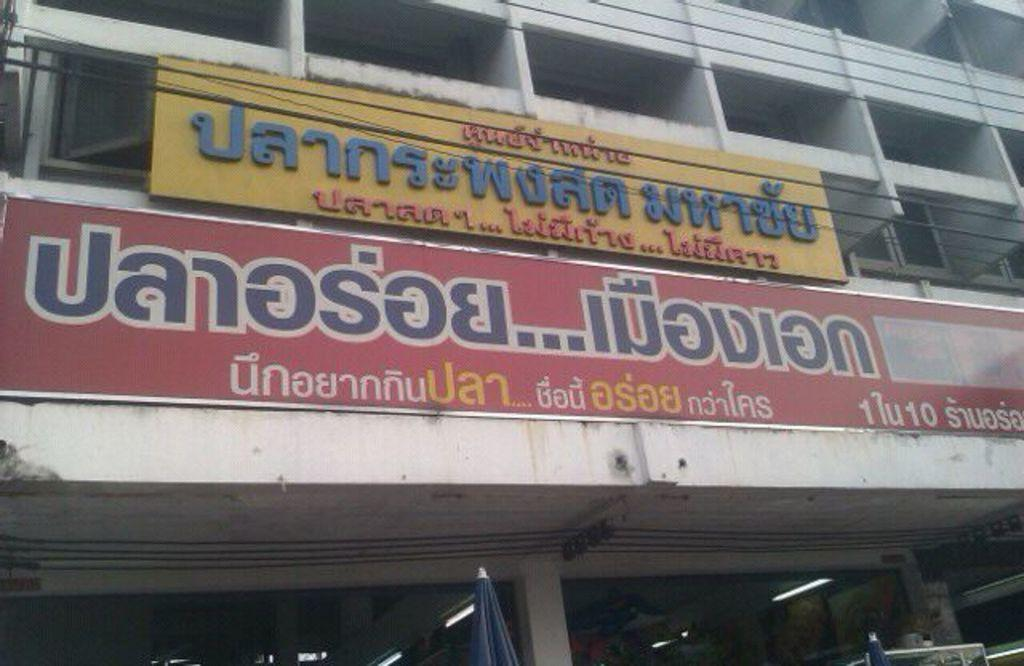What is the main subject of the image? The main subject of the image is a building. Can you describe any specific features of the building? Yes, the building has name boards on it. What type of lighting can be seen at the bottom of the image? There are tube lights at the bottom of the image. Can you tell me how many hydrants are visible in the image? There are no hydrants present in the image. What emotion does the building express in the image? Buildings do not express emotions, so this question cannot be answered. 